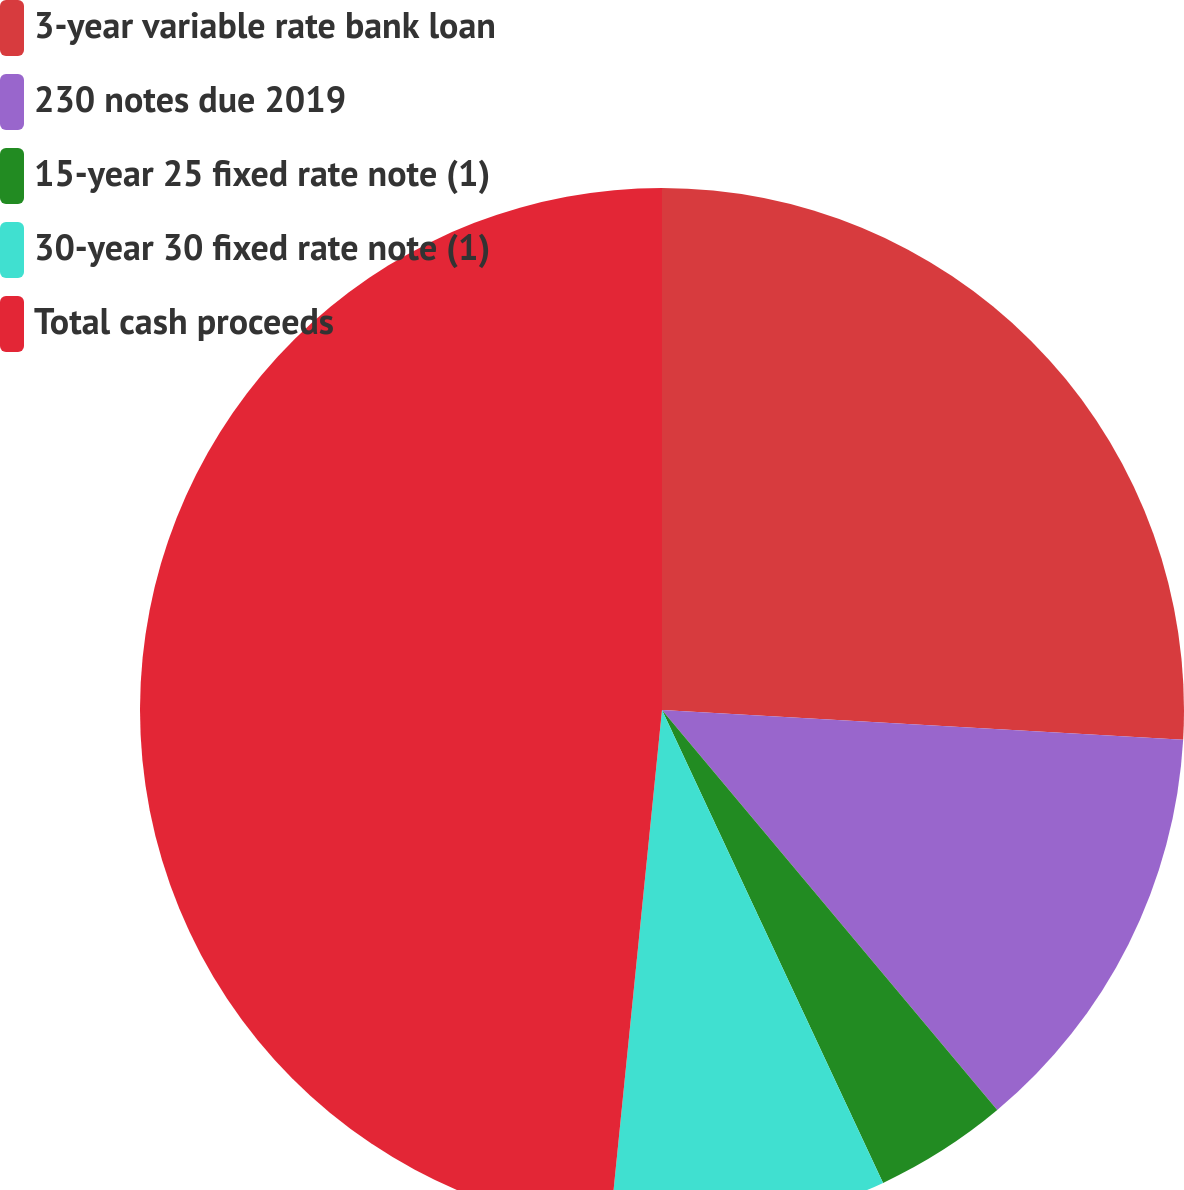<chart> <loc_0><loc_0><loc_500><loc_500><pie_chart><fcel>3-year variable rate bank loan<fcel>230 notes due 2019<fcel>15-year 25 fixed rate note (1)<fcel>30-year 30 fixed rate note (1)<fcel>Total cash proceeds<nl><fcel>25.91%<fcel>12.99%<fcel>4.14%<fcel>8.56%<fcel>48.4%<nl></chart> 